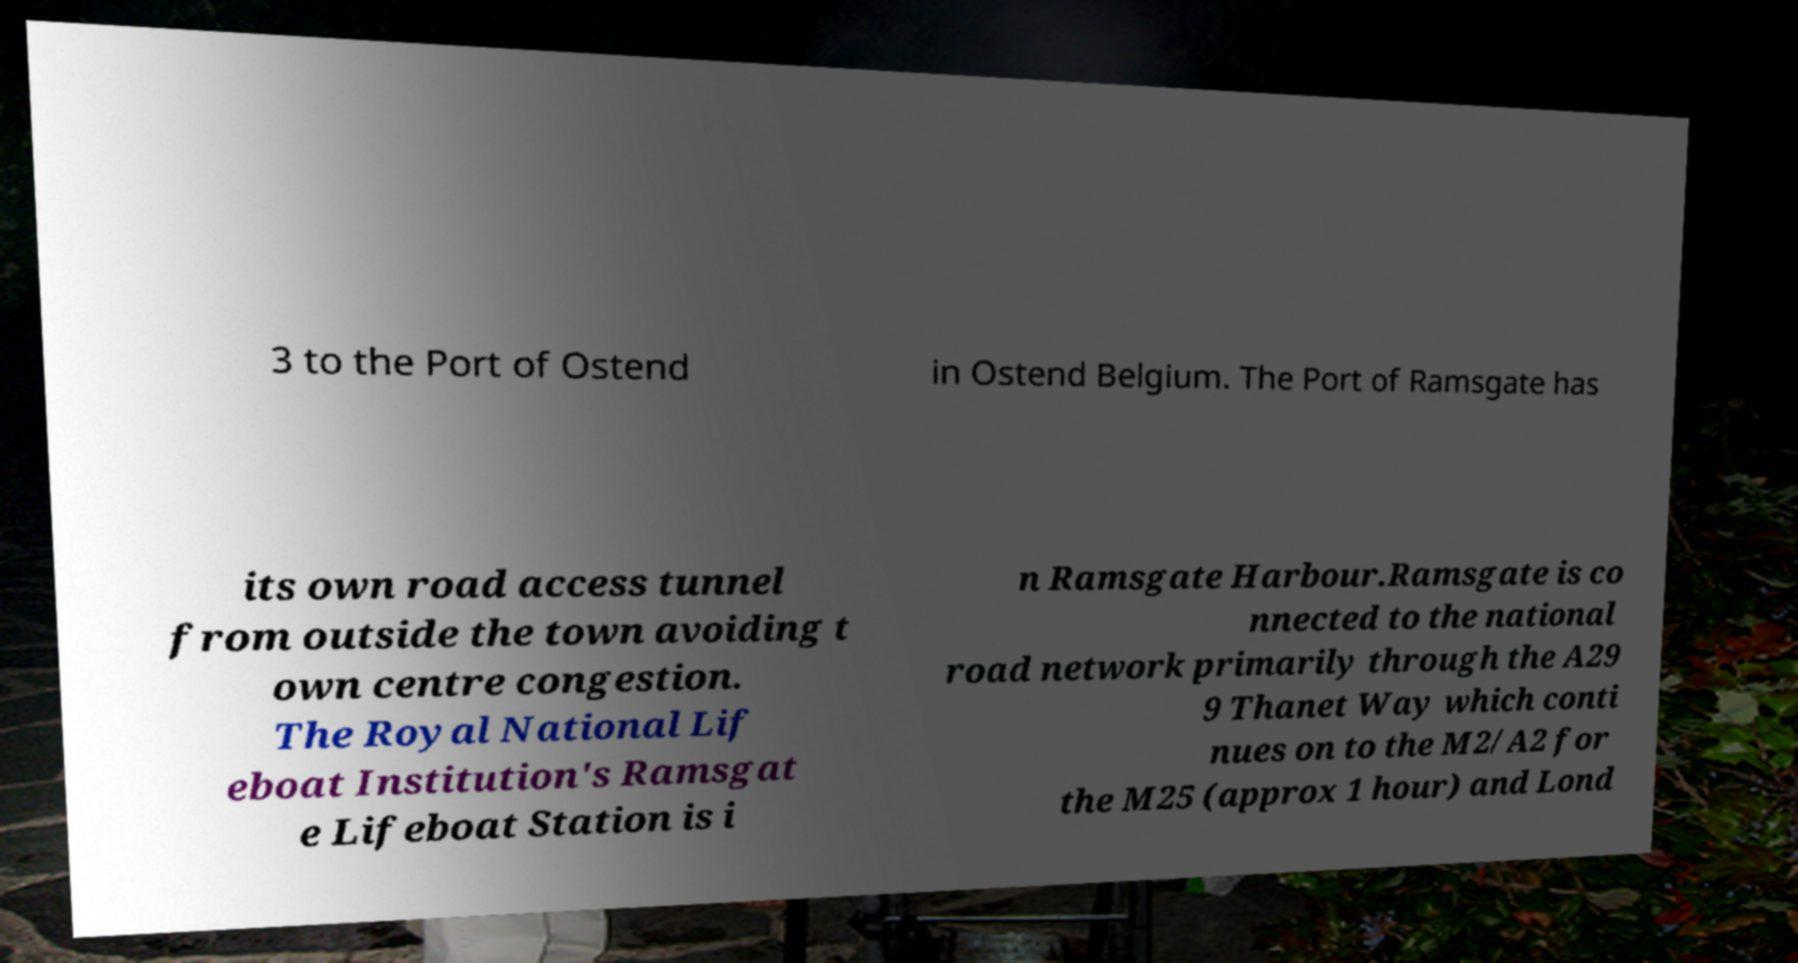Could you extract and type out the text from this image? 3 to the Port of Ostend in Ostend Belgium. The Port of Ramsgate has its own road access tunnel from outside the town avoiding t own centre congestion. The Royal National Lif eboat Institution's Ramsgat e Lifeboat Station is i n Ramsgate Harbour.Ramsgate is co nnected to the national road network primarily through the A29 9 Thanet Way which conti nues on to the M2/A2 for the M25 (approx 1 hour) and Lond 